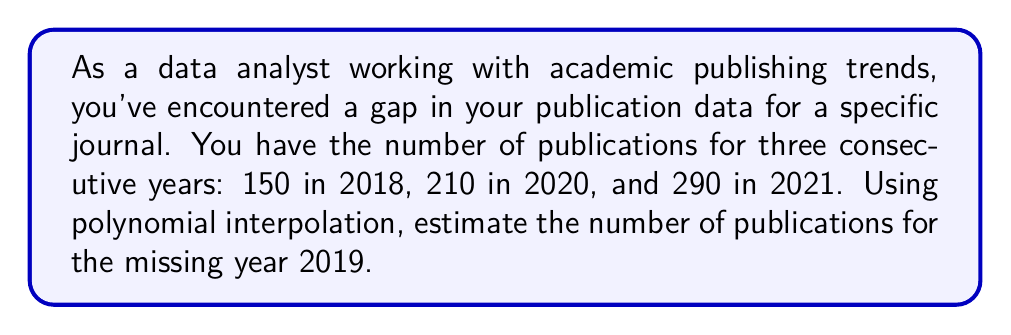Give your solution to this math problem. To solve this problem, we'll use Lagrange polynomial interpolation. The steps are as follows:

1) First, let's define our known points:
   $(x_0, y_0) = (0, 150)$, $(x_1, y_1) = (2, 210)$, $(x_2, y_2) = (3, 290)$
   Where $x$ represents the number of years since 2018, and $y$ represents the number of publications.

2) The Lagrange interpolation polynomial is given by:
   $$L(x) = y_0\frac{(x-x_1)(x-x_2)}{(x_0-x_1)(x_0-x_2)} + y_1\frac{(x-x_0)(x-x_2)}{(x_1-x_0)(x_1-x_2)} + y_2\frac{(x-x_0)(x-x_1)}{(x_2-x_0)(x_2-x_1)}$$

3) Substituting our values:
   $$L(x) = 150\frac{(x-2)(x-3)}{(0-2)(0-3)} + 210\frac{(x-0)(x-3)}{(2-0)(2-3)} + 290\frac{(x-0)(x-2)}{(3-0)(3-2)}$$

4) Simplifying:
   $$L(x) = 150\frac{(x-2)(x-3)}{6} + 210\frac{x(x-3)}{-2} + 290\frac{x(x-2)}{6}$$

5) To find the number of publications in 2019, we need to calculate $L(1)$:
   $$L(1) = 150\frac{(1-2)(1-3)}{6} + 210\frac{1(1-3)}{-2} + 290\frac{1(1-2)}{6}$$

6) Evaluating:
   $$L(1) = 150\frac{(-1)(-2)}{6} + 210\frac{(-2)}{-2} + 290\frac{(-1)}{6}$$
   $$L(1) = 50 + 210 - 48.33$$
   $$L(1) = 211.67$$

7) Rounding to the nearest whole number (as we can't have a fractional number of publications):
   $$L(1) \approx 212$$
Answer: 212 publications 